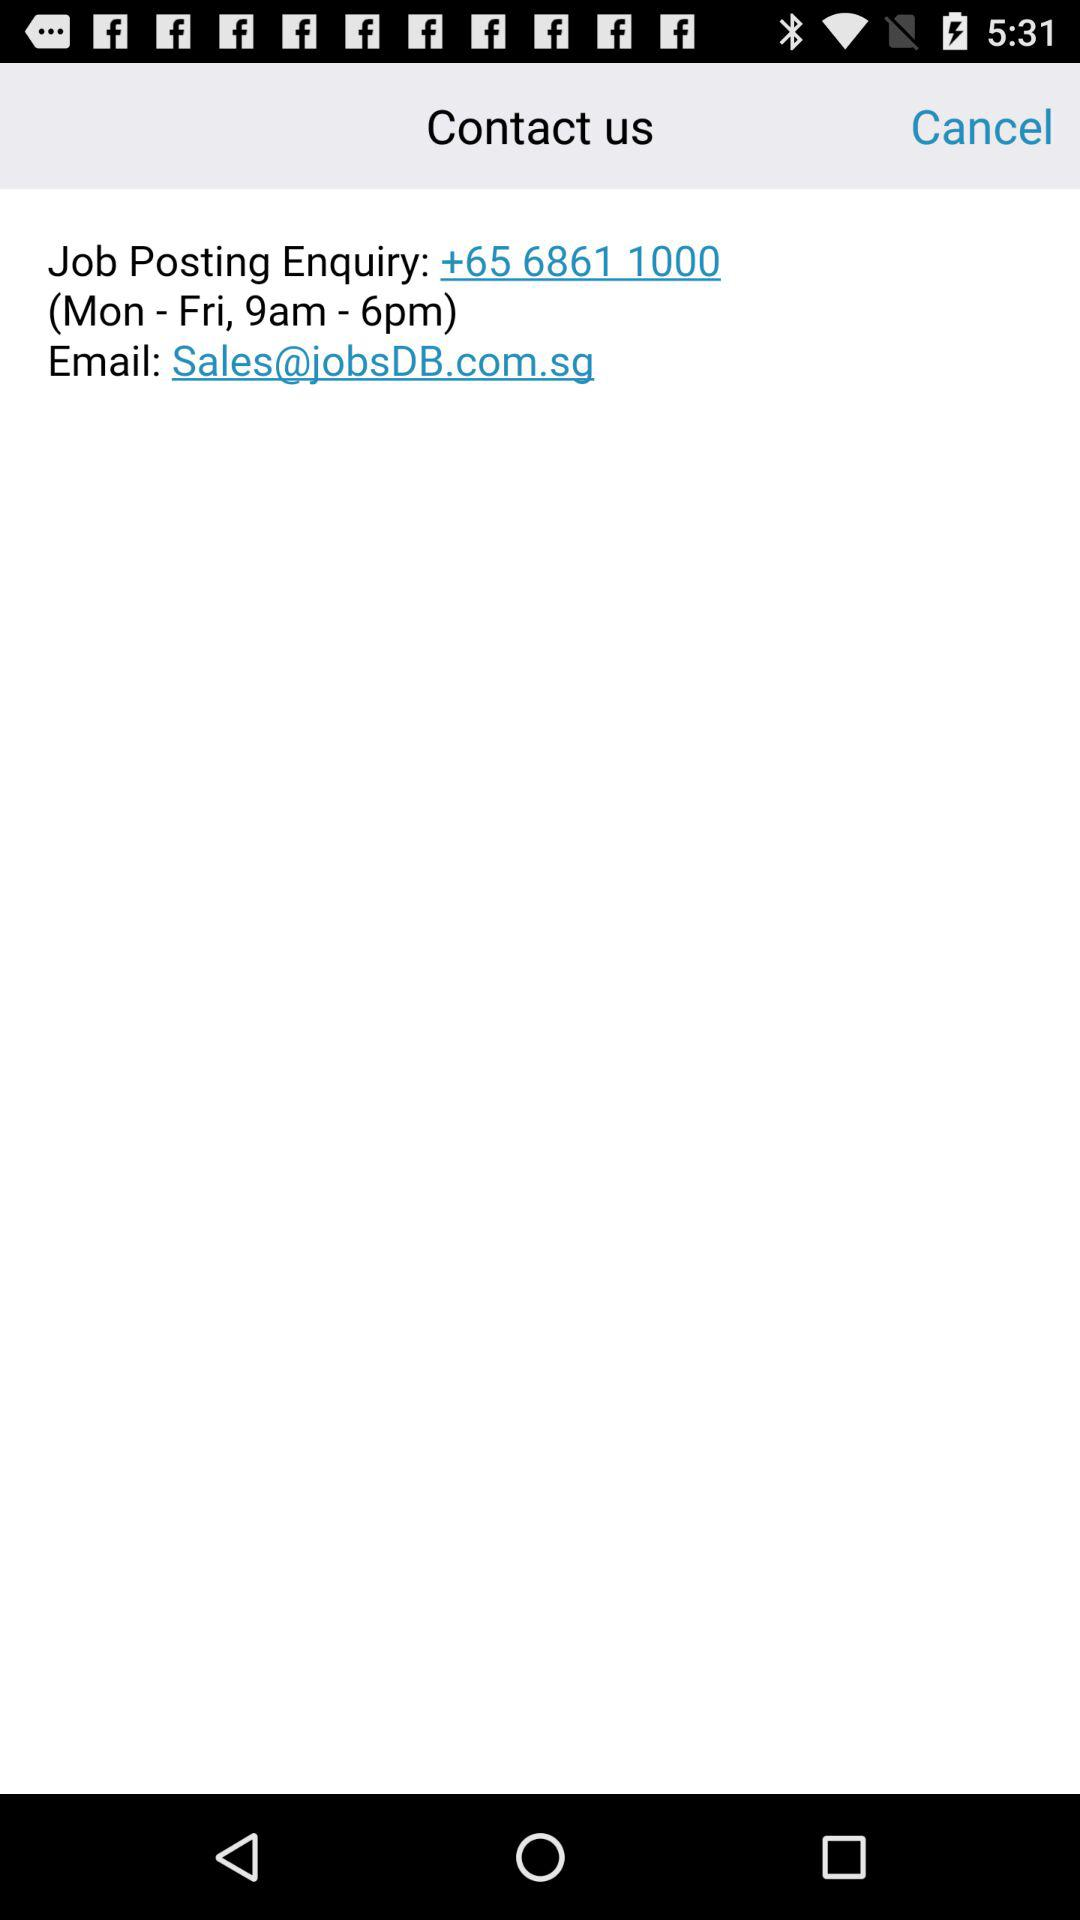What is the phone number? The phone number is +65 6861 1000. 